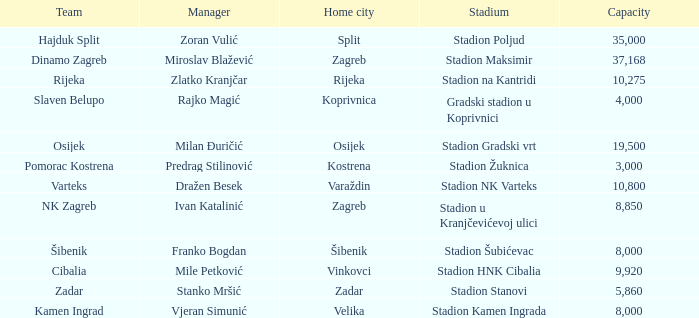What is the stadium of the NK Zagreb? Stadion u Kranjčevićevoj ulici. 